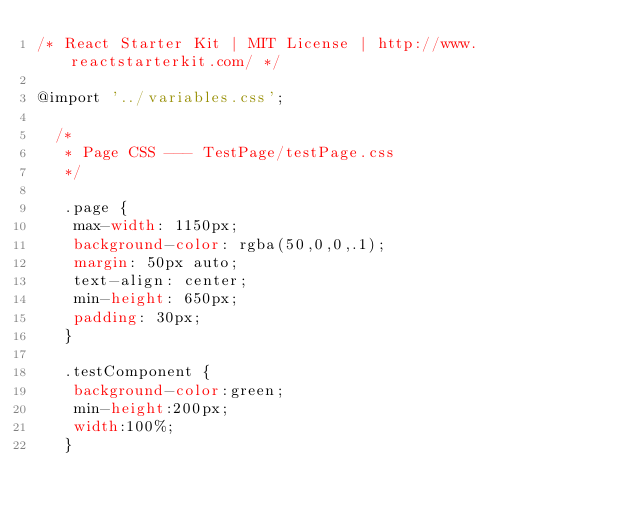<code> <loc_0><loc_0><loc_500><loc_500><_CSS_>/* React Starter Kit | MIT License | http://www.reactstarterkit.com/ */

@import '../variables.css';

  /*
   * Page CSS --- TestPage/testPage.css
   */

   .page {
    max-width: 1150px;
    background-color: rgba(50,0,0,.1);
    margin: 50px auto;
    text-align: center;
    min-height: 650px;
    padding: 30px;
   }

   .testComponent {
    background-color:green;
    min-height:200px;
    width:100%;
   }
</code> 